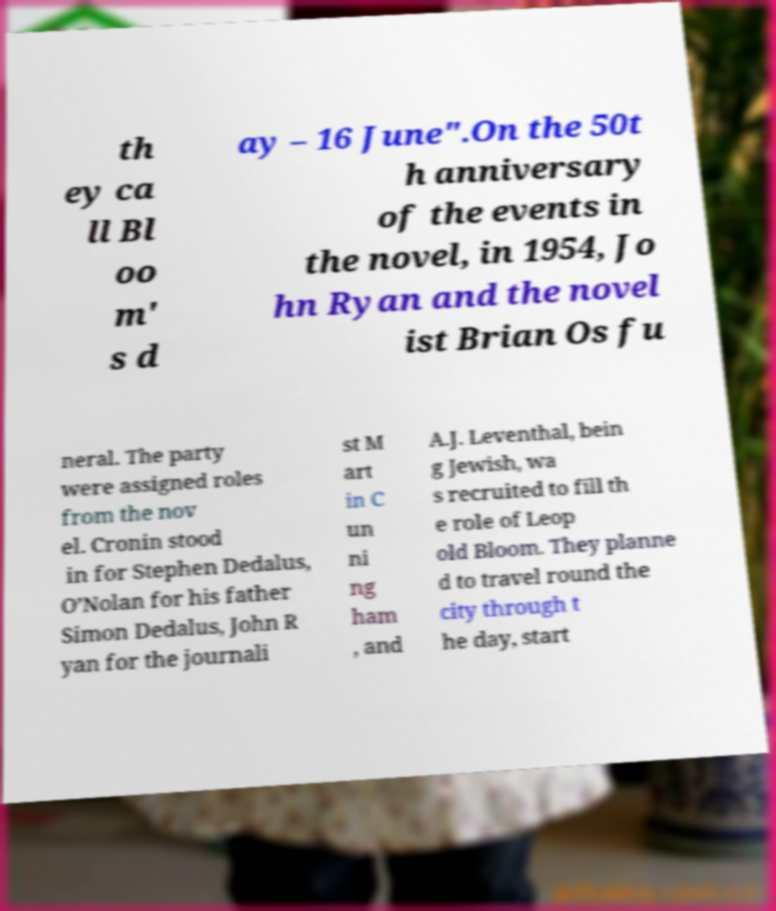There's text embedded in this image that I need extracted. Can you transcribe it verbatim? th ey ca ll Bl oo m' s d ay – 16 June".On the 50t h anniversary of the events in the novel, in 1954, Jo hn Ryan and the novel ist Brian Os fu neral. The party were assigned roles from the nov el. Cronin stood in for Stephen Dedalus, O’Nolan for his father Simon Dedalus, John R yan for the journali st M art in C un ni ng ham , and A.J. Leventhal, bein g Jewish, wa s recruited to fill th e role of Leop old Bloom. They planne d to travel round the city through t he day, start 